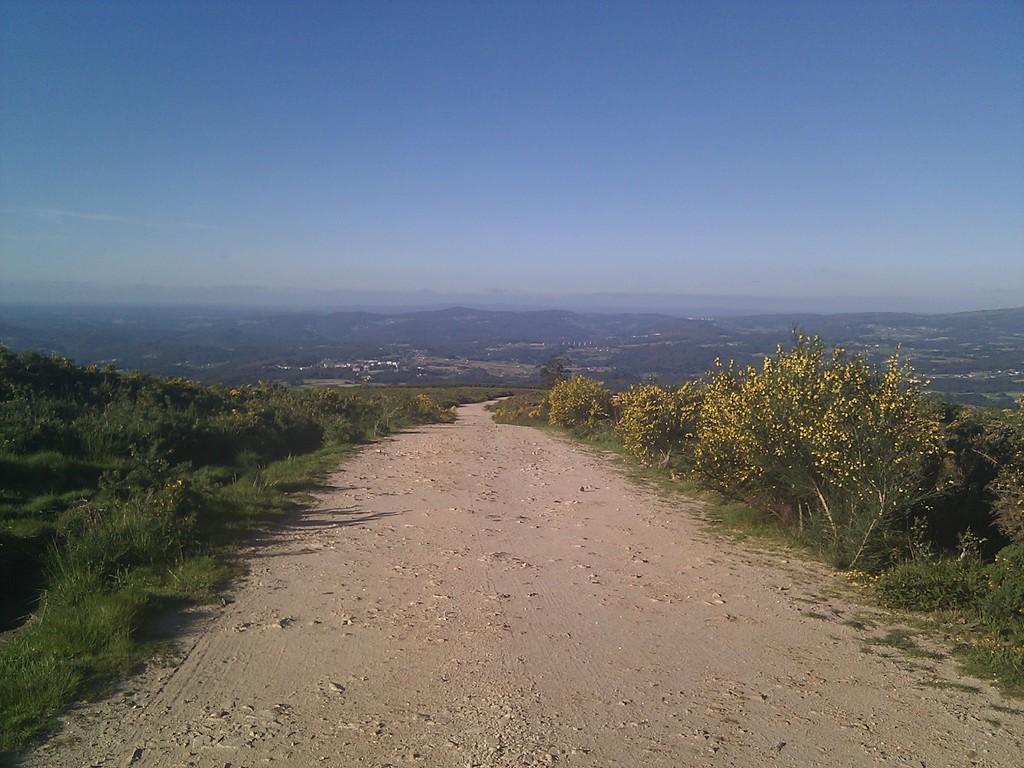Can you describe this image briefly? In this image we can see ground, grass, plants, trees, and flowers. In the background there is sky. 